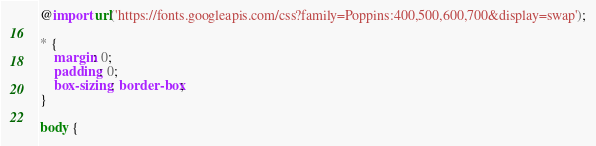Convert code to text. <code><loc_0><loc_0><loc_500><loc_500><_CSS_>@import url('https://fonts.googleapis.com/css?family=Poppins:400,500,600,700&display=swap');

* {
    margin: 0;
    padding: 0;
    box-sizing: border-box;
}

body {</code> 